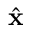Convert formula to latex. <formula><loc_0><loc_0><loc_500><loc_500>\hat { \mathbf x }</formula> 